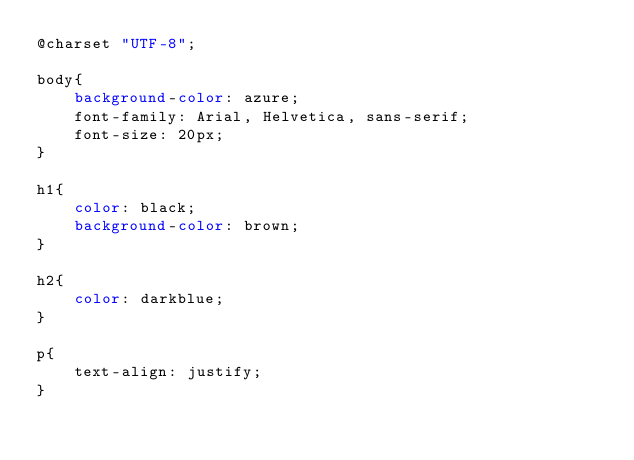Convert code to text. <code><loc_0><loc_0><loc_500><loc_500><_CSS_>@charset "UTF-8";

body{
    background-color: azure;
    font-family: Arial, Helvetica, sans-serif;
    font-size: 20px;
}

h1{
    color: black;
    background-color: brown;
}

h2{
    color: darkblue;
}

p{
    text-align: justify;
}</code> 